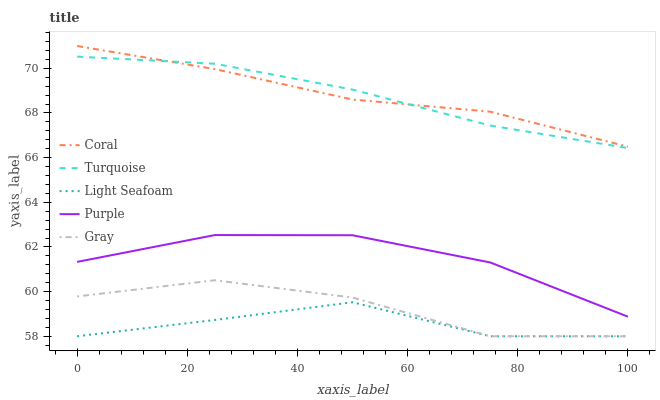Does Light Seafoam have the minimum area under the curve?
Answer yes or no. Yes. Does Coral have the maximum area under the curve?
Answer yes or no. Yes. Does Gray have the minimum area under the curve?
Answer yes or no. No. Does Gray have the maximum area under the curve?
Answer yes or no. No. Is Turquoise the smoothest?
Answer yes or no. Yes. Is Gray the roughest?
Answer yes or no. Yes. Is Coral the smoothest?
Answer yes or no. No. Is Coral the roughest?
Answer yes or no. No. Does Gray have the lowest value?
Answer yes or no. Yes. Does Coral have the lowest value?
Answer yes or no. No. Does Coral have the highest value?
Answer yes or no. Yes. Does Gray have the highest value?
Answer yes or no. No. Is Light Seafoam less than Coral?
Answer yes or no. Yes. Is Purple greater than Gray?
Answer yes or no. Yes. Does Gray intersect Light Seafoam?
Answer yes or no. Yes. Is Gray less than Light Seafoam?
Answer yes or no. No. Is Gray greater than Light Seafoam?
Answer yes or no. No. Does Light Seafoam intersect Coral?
Answer yes or no. No. 